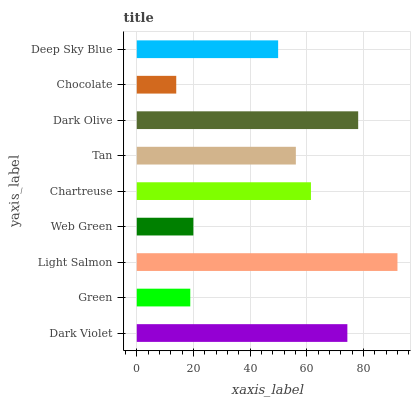Is Chocolate the minimum?
Answer yes or no. Yes. Is Light Salmon the maximum?
Answer yes or no. Yes. Is Green the minimum?
Answer yes or no. No. Is Green the maximum?
Answer yes or no. No. Is Dark Violet greater than Green?
Answer yes or no. Yes. Is Green less than Dark Violet?
Answer yes or no. Yes. Is Green greater than Dark Violet?
Answer yes or no. No. Is Dark Violet less than Green?
Answer yes or no. No. Is Tan the high median?
Answer yes or no. Yes. Is Tan the low median?
Answer yes or no. Yes. Is Dark Violet the high median?
Answer yes or no. No. Is Chocolate the low median?
Answer yes or no. No. 